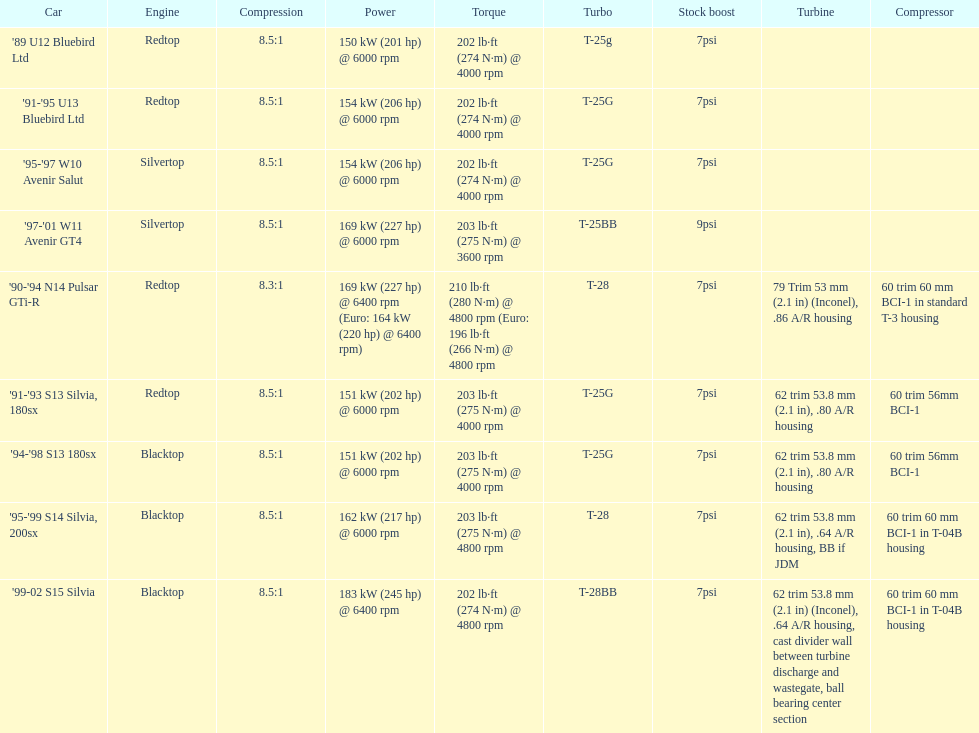What cars are there? '89 U12 Bluebird Ltd, 7psi, '91-'95 U13 Bluebird Ltd, 7psi, '95-'97 W10 Avenir Salut, 7psi, '97-'01 W11 Avenir GT4, 9psi, '90-'94 N14 Pulsar GTi-R, 7psi, '91-'93 S13 Silvia, 180sx, 7psi, '94-'98 S13 180sx, 7psi, '95-'99 S14 Silvia, 200sx, 7psi, '99-02 S15 Silvia, 7psi. Which stock boost is over 7psi? '97-'01 W11 Avenir GT4, 9psi. What car is it? '97-'01 W11 Avenir GT4. 